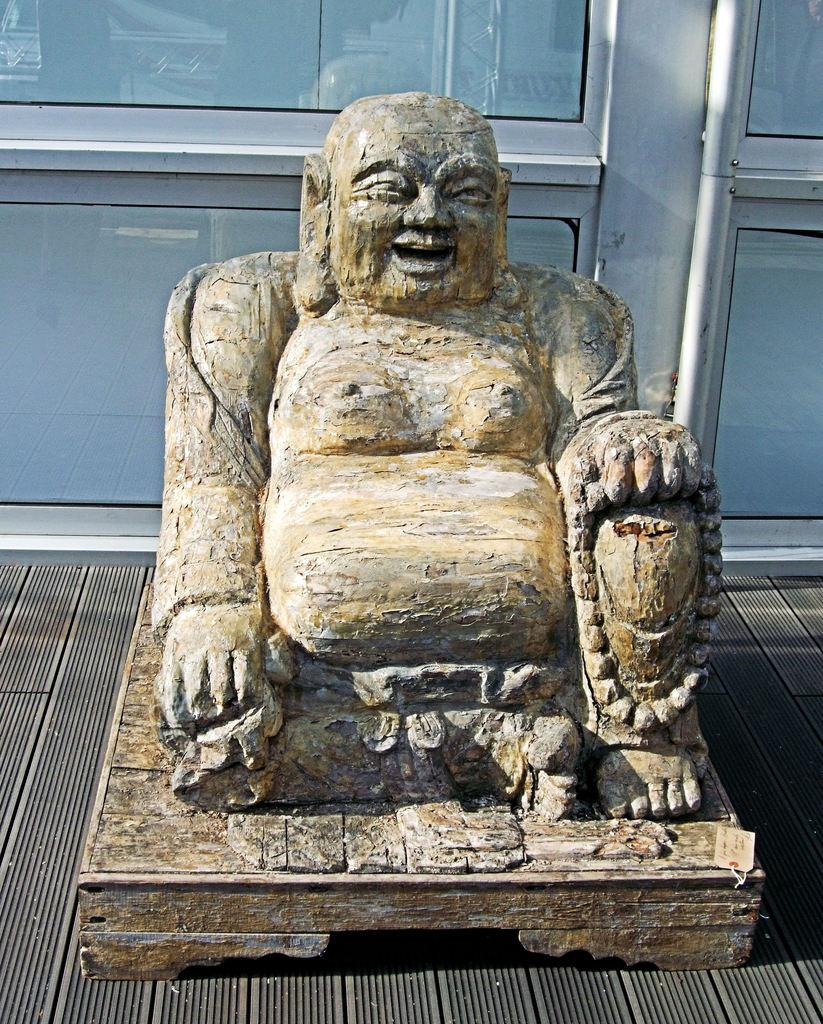What is the main subject of the image? There is a statue of the laughing buddha in the image. What can be seen in the background of the image? There are glass doors in the background of the image. What type of leather can be seen on the ghost in the image? There is no ghost or leather present in the image; it features a statue of the laughing buddha and glass doors in the background. 